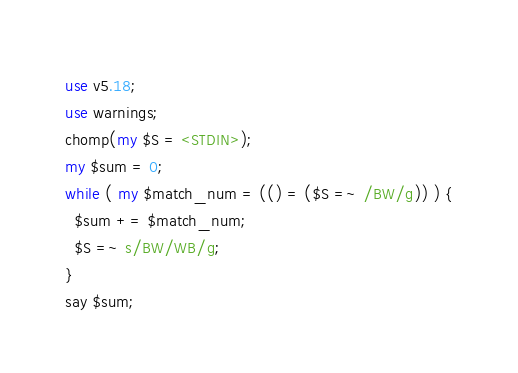<code> <loc_0><loc_0><loc_500><loc_500><_Perl_>use v5.18;
use warnings;
chomp(my $S = <STDIN>);
my $sum = 0;
while ( my $match_num = (() = ($S =~ /BW/g)) ) {
  $sum += $match_num;
  $S =~ s/BW/WB/g;
}
say $sum;
</code> 